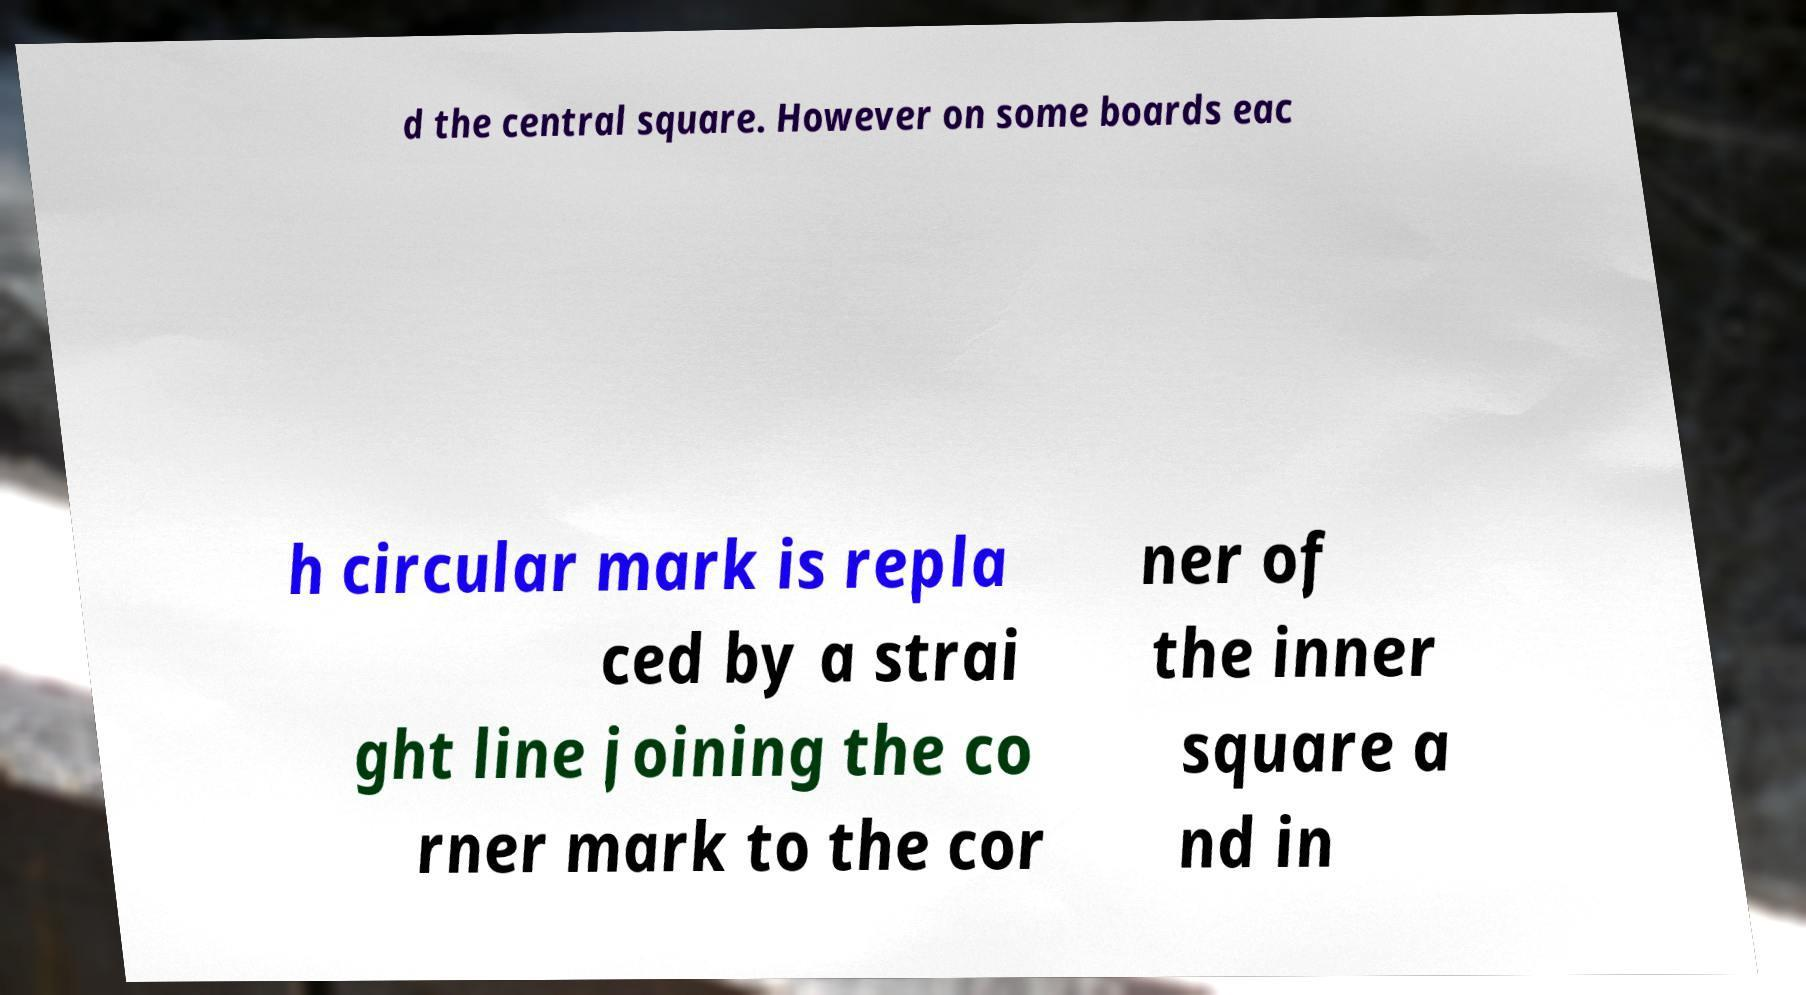Can you accurately transcribe the text from the provided image for me? d the central square. However on some boards eac h circular mark is repla ced by a strai ght line joining the co rner mark to the cor ner of the inner square a nd in 